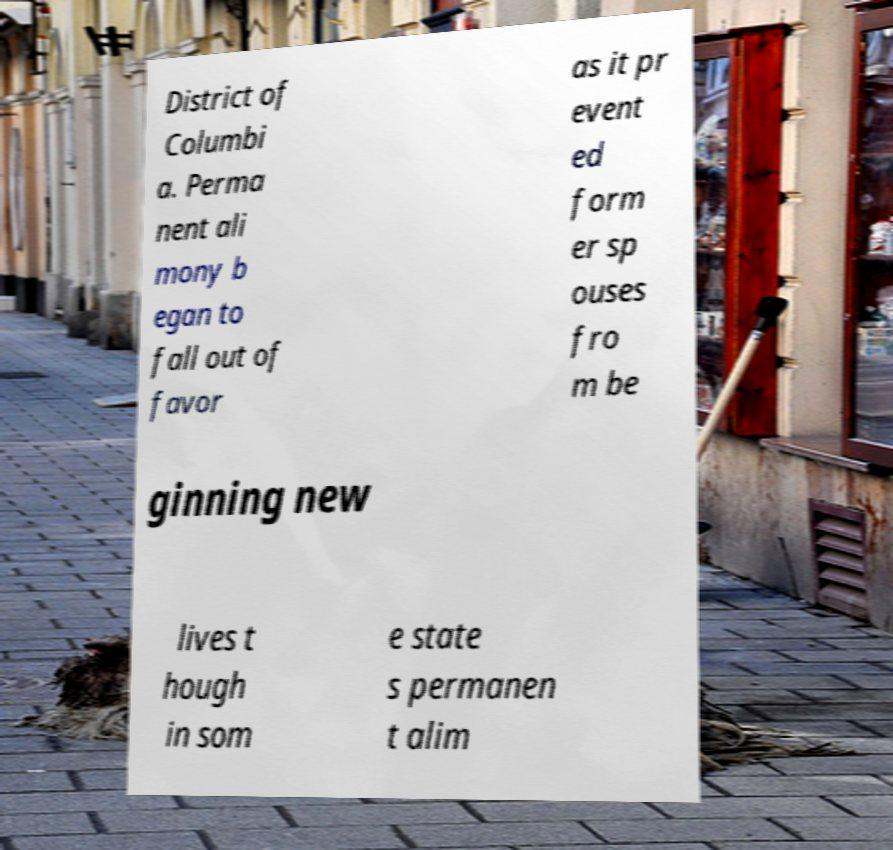Can you accurately transcribe the text from the provided image for me? District of Columbi a. Perma nent ali mony b egan to fall out of favor as it pr event ed form er sp ouses fro m be ginning new lives t hough in som e state s permanen t alim 